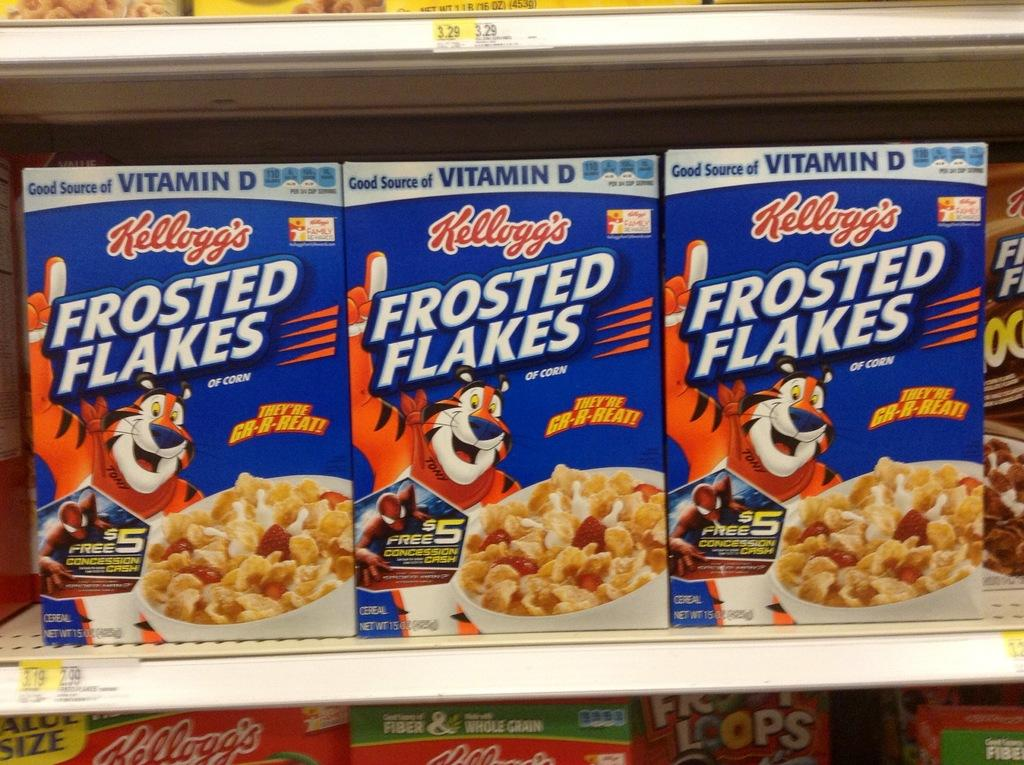What type of product is featured in the image? The image features flakes boxes. How are the flakes boxes arranged in the image? The flakes boxes are in a rack. Are there any indications of the price of the flakes boxes in the image? Yes, the flakes boxes have price tags on them. Where are the flakes boxes and rack located in the image? The flakes boxes and rack are in the foreground of the image. What type of sweater is the person wearing in the image? There is no person wearing a sweater in the image; it features flakes boxes in a rack. How does the hair of the person in the image look? There is no person present in the image, so we cannot describe their hair. 